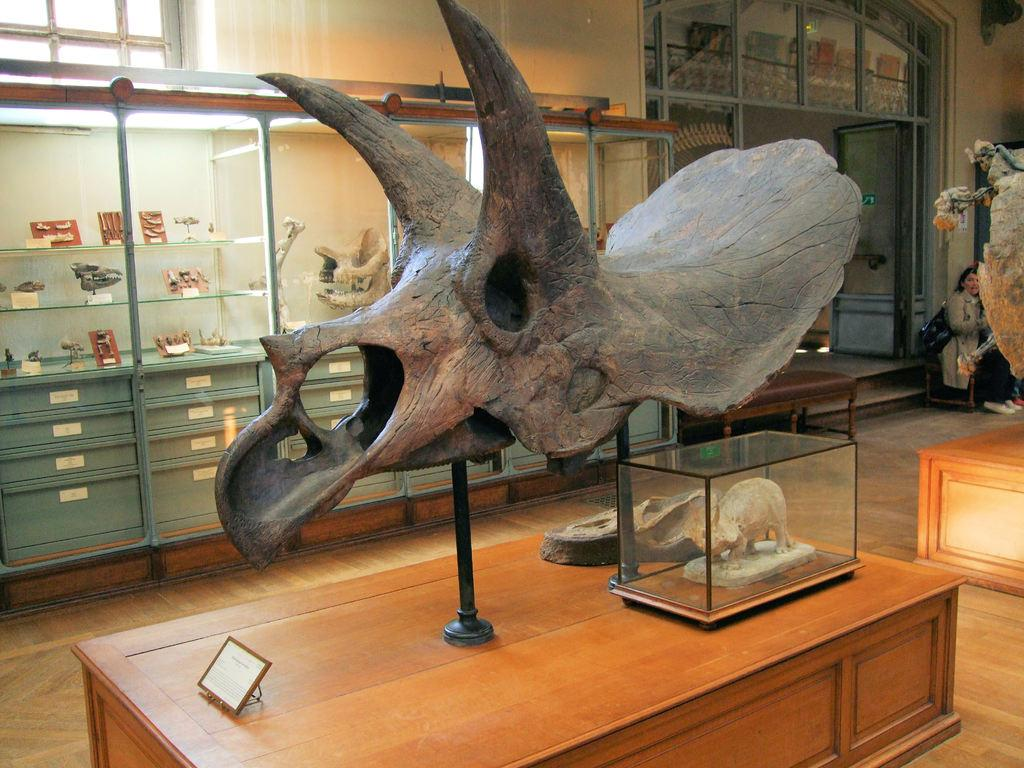What is the main subject of the image? There is a dinosaur skull in the image. Where is the image taken? The image is set in a museum. What other items can be seen in the background of the image? Animal bones are visible in the background. What is located on the right side of the image? There is a door on the right side of the image. What type of stamp is on the dinosaur skull in the image? There is no stamp present on the dinosaur skull in the image. 